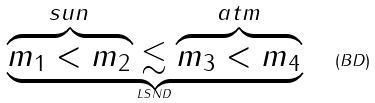Convert formula to latex. <formula><loc_0><loc_0><loc_500><loc_500>\underbrace { \overbrace { m _ { 1 } < m _ { 2 } } ^ { s u n } \lesssim \overbrace { m _ { 3 } < m _ { 4 } } ^ { a t m } } _ { L S N D } \quad ( B D )</formula> 